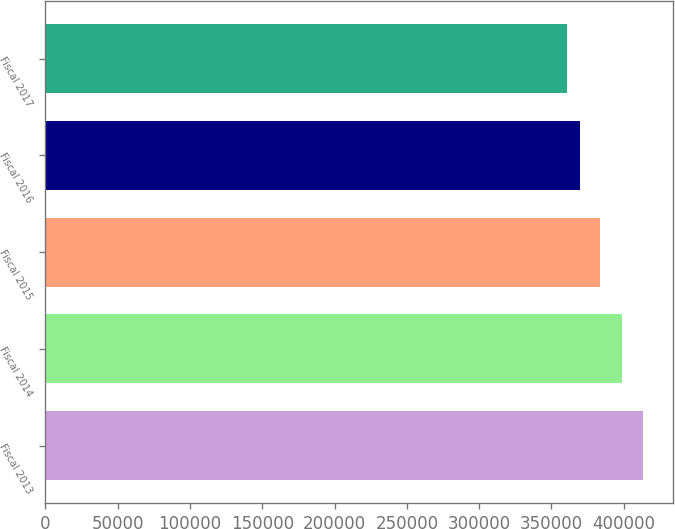Convert chart. <chart><loc_0><loc_0><loc_500><loc_500><bar_chart><fcel>Fiscal 2013<fcel>Fiscal 2014<fcel>Fiscal 2015<fcel>Fiscal 2016<fcel>Fiscal 2017<nl><fcel>413310<fcel>398747<fcel>383914<fcel>370106<fcel>361061<nl></chart> 